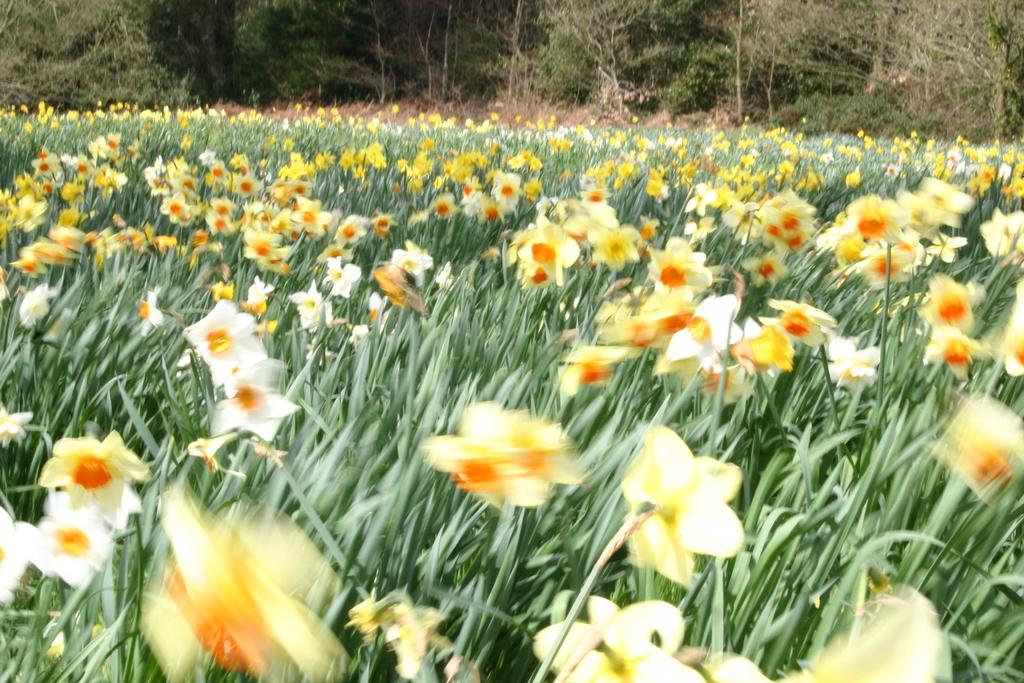What colors are the flowers in the image? The flowers in the image are yellow and orange. What type of flora can be seen in the image? There are flowers and plants visible in the image. What can be seen in the background of the image? There are trees in the background of the image. What direction is the jellyfish swimming in the image? There are no jellyfish present in the image; it features flowers, plants, and trees. 